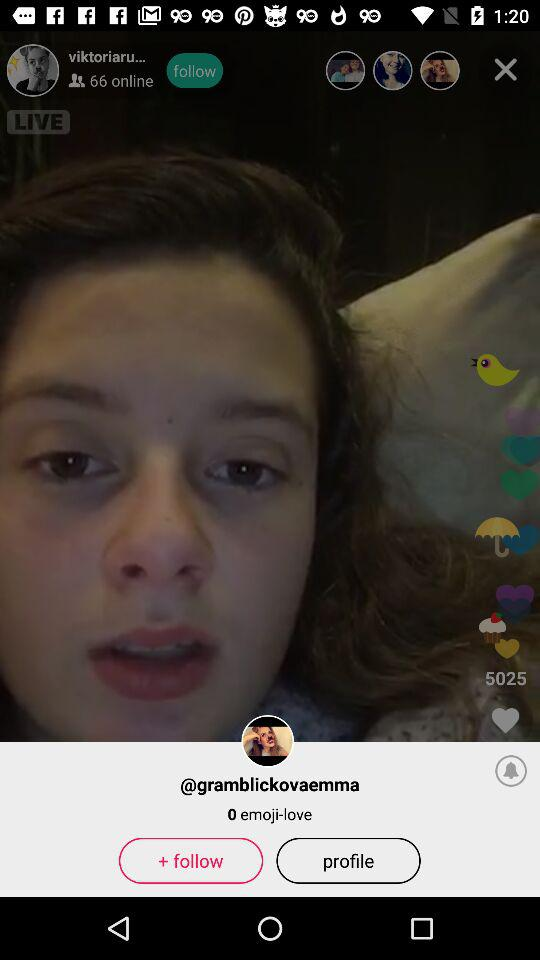What is the count of "emoji-love"? The count is 0. 